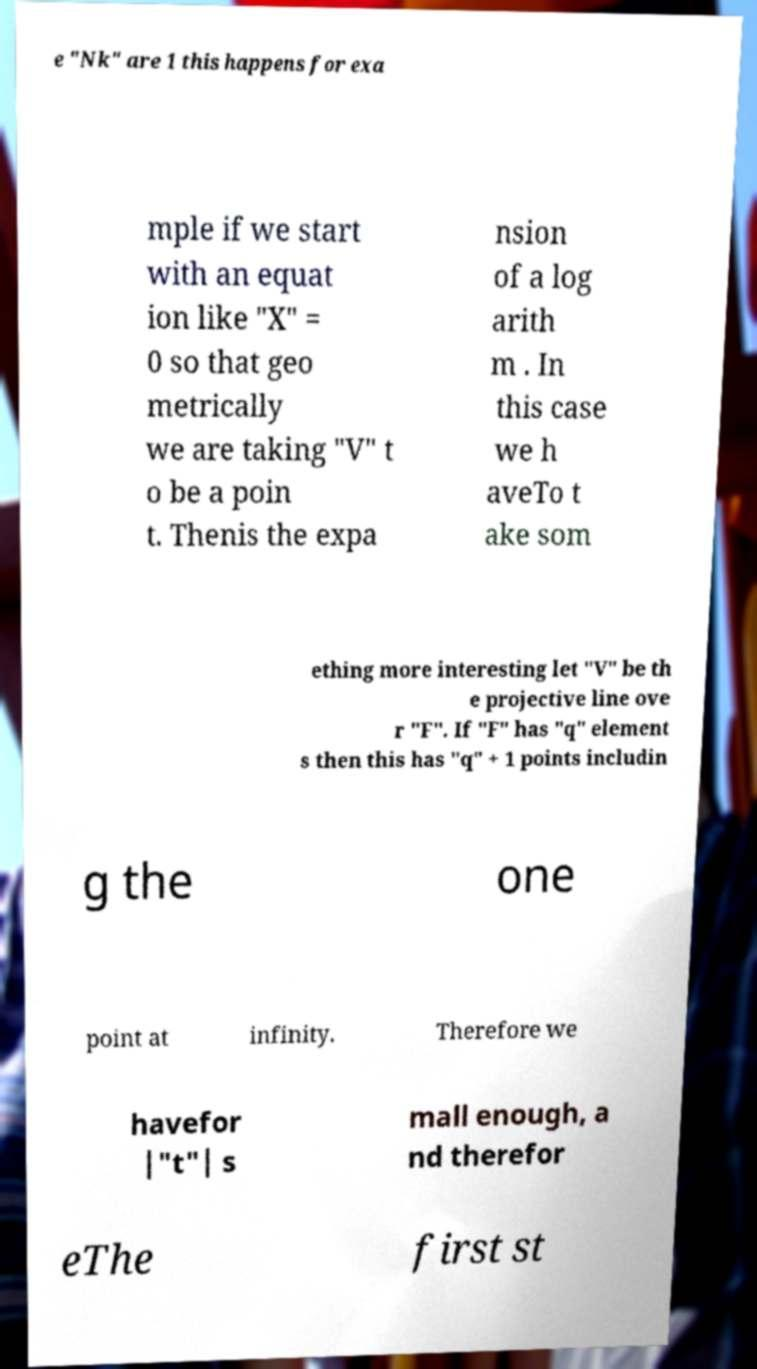There's text embedded in this image that I need extracted. Can you transcribe it verbatim? e "Nk" are 1 this happens for exa mple if we start with an equat ion like "X" = 0 so that geo metrically we are taking "V" t o be a poin t. Thenis the expa nsion of a log arith m . In this case we h aveTo t ake som ething more interesting let "V" be th e projective line ove r "F". If "F" has "q" element s then this has "q" + 1 points includin g the one point at infinity. Therefore we havefor |"t"| s mall enough, a nd therefor eThe first st 